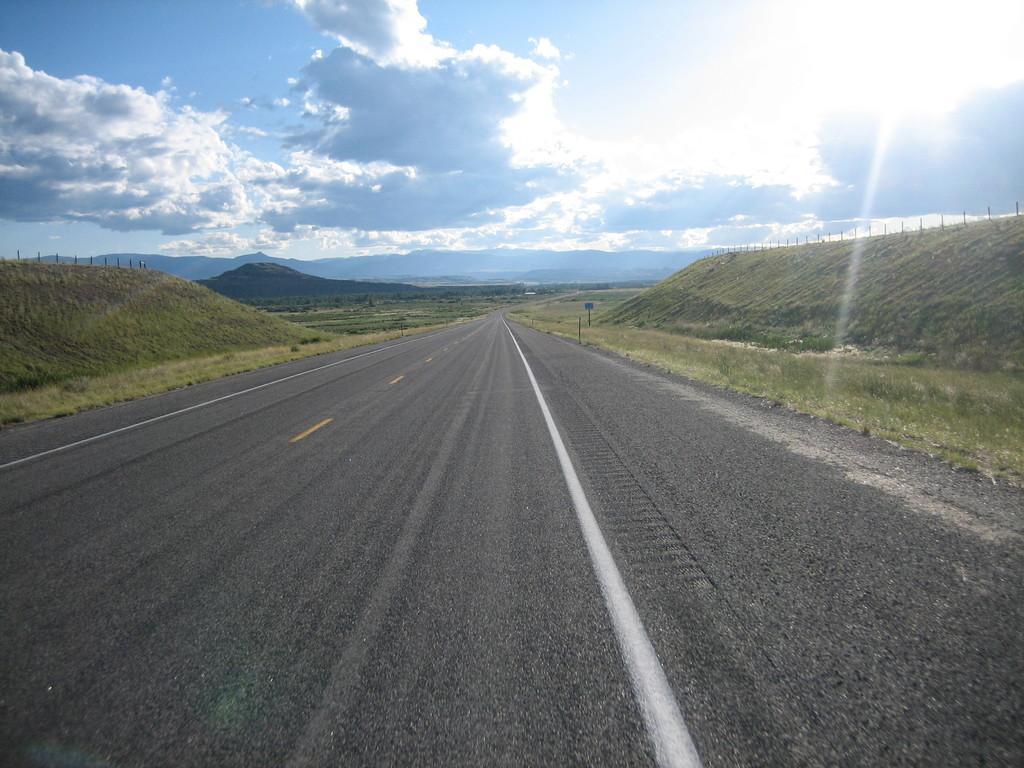Please provide a concise description of this image. In the foreground of the image we can see the road. To the right side, we can see a cliff with some poles on it. On the left side, we can see group of mountains and in the background, we can see a cloudy sky. 